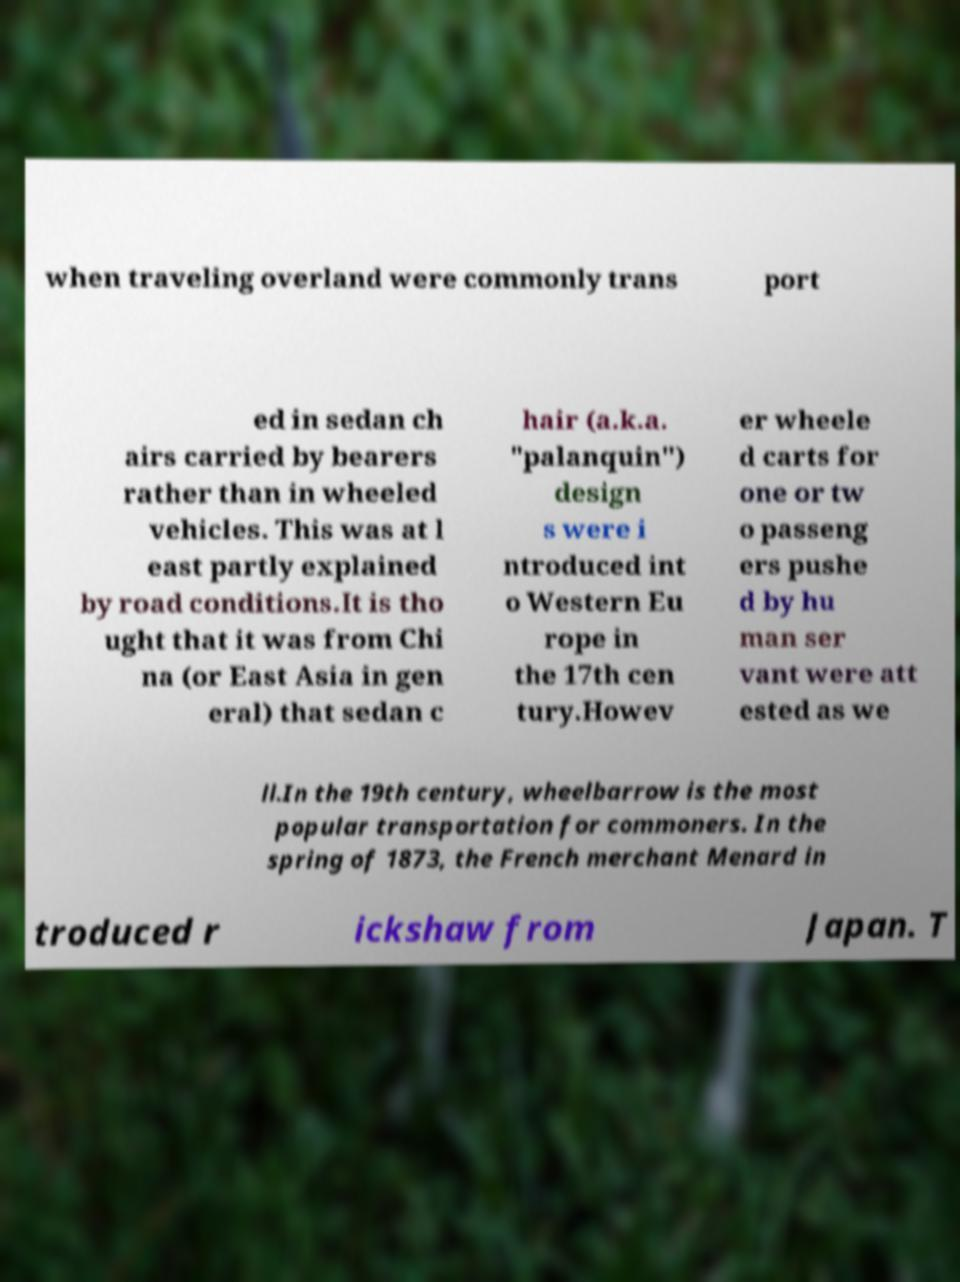I need the written content from this picture converted into text. Can you do that? when traveling overland were commonly trans port ed in sedan ch airs carried by bearers rather than in wheeled vehicles. This was at l east partly explained by road conditions.It is tho ught that it was from Chi na (or East Asia in gen eral) that sedan c hair (a.k.a. "palanquin") design s were i ntroduced int o Western Eu rope in the 17th cen tury.Howev er wheele d carts for one or tw o passeng ers pushe d by hu man ser vant were att ested as we ll.In the 19th century, wheelbarrow is the most popular transportation for commoners. In the spring of 1873, the French merchant Menard in troduced r ickshaw from Japan. T 